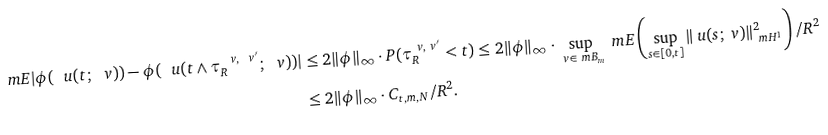<formula> <loc_0><loc_0><loc_500><loc_500>\ m E | \phi ( \ u ( t ; \ v ) ) - \phi ( \ u ( t \wedge \tau ^ { \ v , \ v ^ { \prime } } _ { R } ; \ v ) ) | & \leq 2 \| \phi \| _ { \infty } \cdot P ( \tau ^ { \ v , \ v ^ { \prime } } _ { R } < t ) \leq 2 \| \phi \| _ { \infty } \cdot \sup _ { \ v \in \ m B _ { m } } \ m E \left ( \sup _ { s \in [ 0 , t ] } \| \ u ( s ; \ v ) \| ^ { 2 } _ { \ m H ^ { 1 } } \right ) / R ^ { 2 } \\ & \leq 2 \| \phi \| _ { \infty } \cdot C _ { t , m , N } / R ^ { 2 } .</formula> 